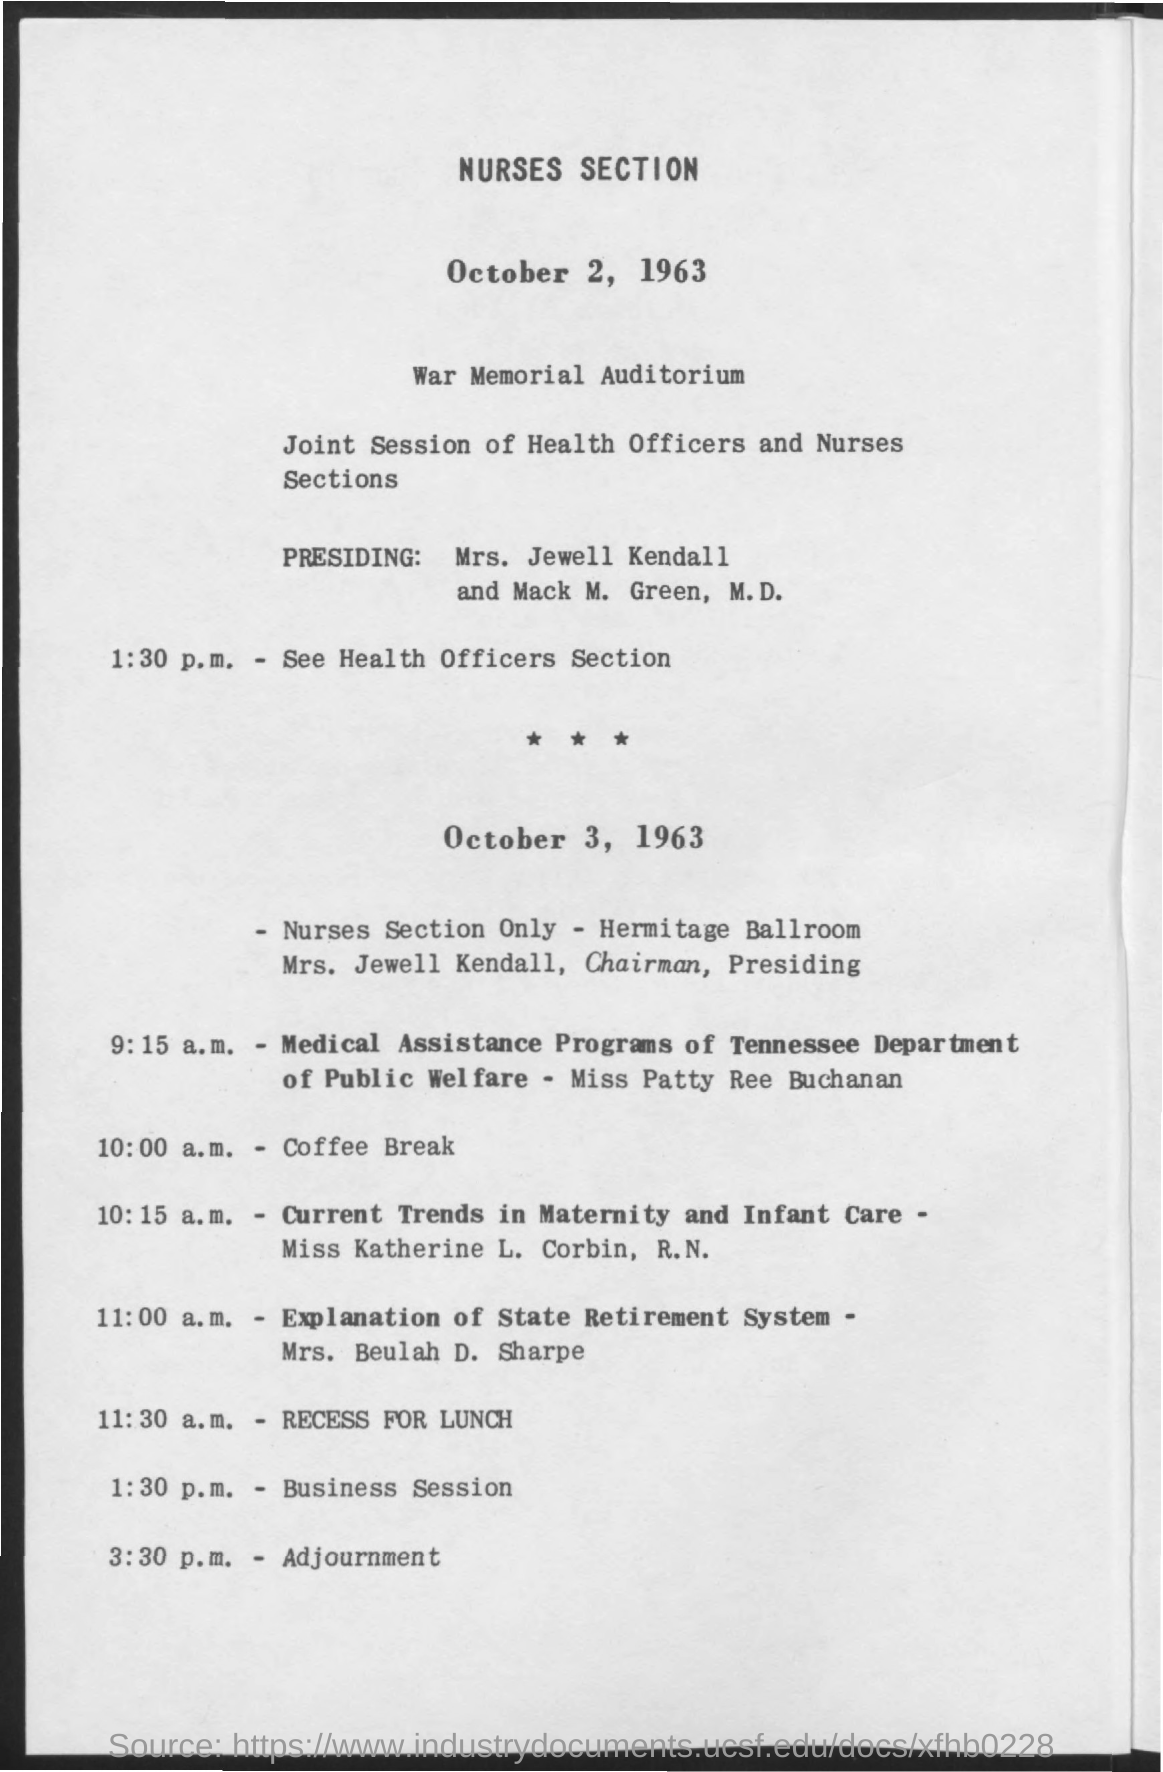Highlight a few significant elements in this photo. It is currently 11:30 a.m. and recess has been scheduled for lunch. The coffee break is scheduled to occur at 10:00 a.m. The business session is scheduled to begin at 1:30 p.m... The adjournment is scheduled for 3:30 p.m. The section is being held at the War Memorial Auditorium. 